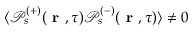Convert formula to latex. <formula><loc_0><loc_0><loc_500><loc_500>\langle \mathcal { P } _ { s } ^ { ( + ) } ( r , \tau ) \mathcal { P } _ { s } ^ { ( - ) } ( r , \tau ) \rangle \neq 0</formula> 